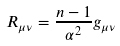<formula> <loc_0><loc_0><loc_500><loc_500>R _ { \mu \nu } = \frac { n - 1 } { \alpha ^ { 2 } } g _ { \mu \nu }</formula> 